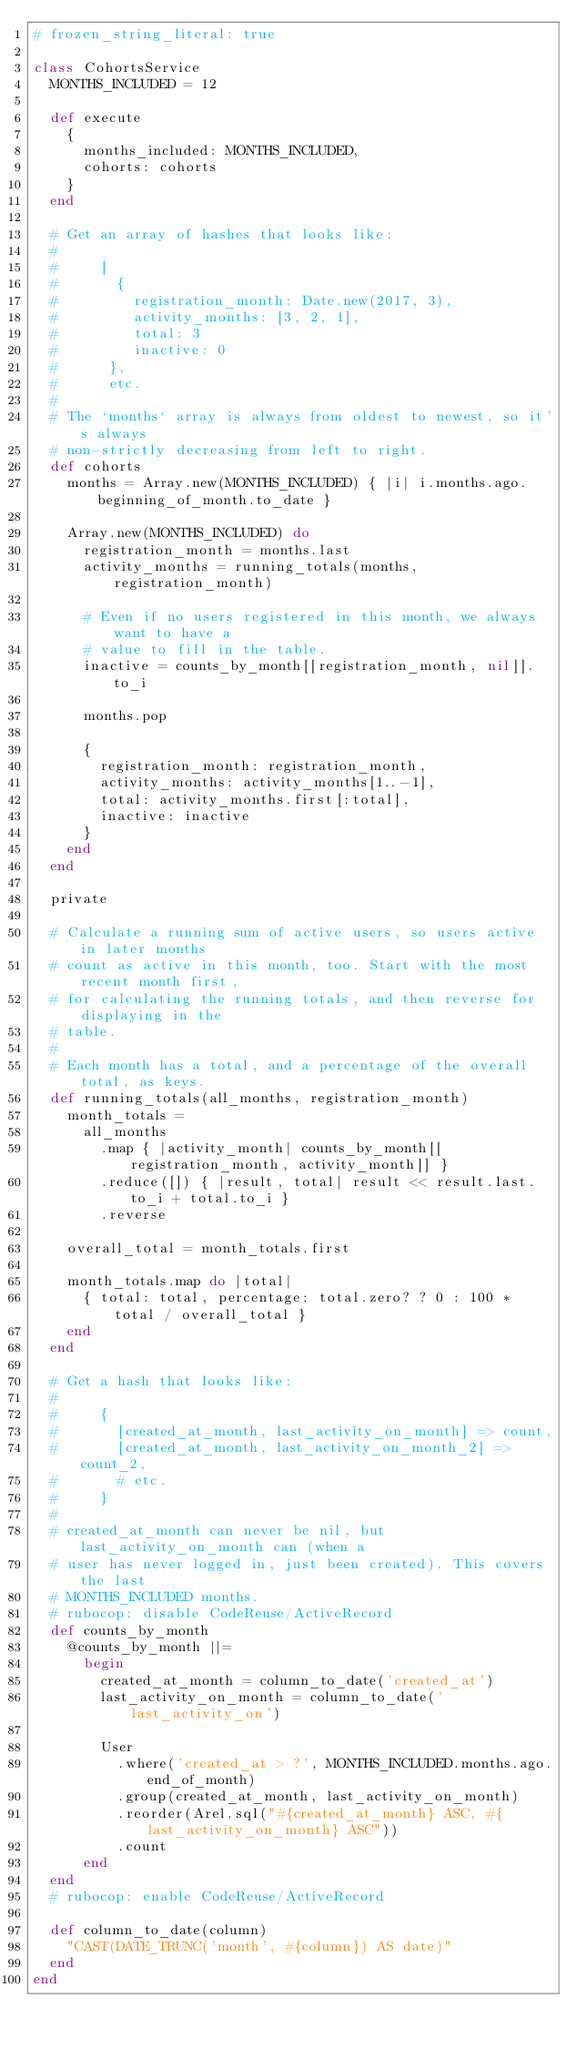Convert code to text. <code><loc_0><loc_0><loc_500><loc_500><_Ruby_># frozen_string_literal: true

class CohortsService
  MONTHS_INCLUDED = 12

  def execute
    {
      months_included: MONTHS_INCLUDED,
      cohorts: cohorts
    }
  end

  # Get an array of hashes that looks like:
  #
  #     [
  #       {
  #         registration_month: Date.new(2017, 3),
  #         activity_months: [3, 2, 1],
  #         total: 3
  #         inactive: 0
  #      },
  #      etc.
  #
  # The `months` array is always from oldest to newest, so it's always
  # non-strictly decreasing from left to right.
  def cohorts
    months = Array.new(MONTHS_INCLUDED) { |i| i.months.ago.beginning_of_month.to_date }

    Array.new(MONTHS_INCLUDED) do
      registration_month = months.last
      activity_months = running_totals(months, registration_month)

      # Even if no users registered in this month, we always want to have a
      # value to fill in the table.
      inactive = counts_by_month[[registration_month, nil]].to_i

      months.pop

      {
        registration_month: registration_month,
        activity_months: activity_months[1..-1],
        total: activity_months.first[:total],
        inactive: inactive
      }
    end
  end

  private

  # Calculate a running sum of active users, so users active in later months
  # count as active in this month, too. Start with the most recent month first,
  # for calculating the running totals, and then reverse for displaying in the
  # table.
  #
  # Each month has a total, and a percentage of the overall total, as keys.
  def running_totals(all_months, registration_month)
    month_totals =
      all_months
        .map { |activity_month| counts_by_month[[registration_month, activity_month]] }
        .reduce([]) { |result, total| result << result.last.to_i + total.to_i }
        .reverse

    overall_total = month_totals.first

    month_totals.map do |total|
      { total: total, percentage: total.zero? ? 0 : 100 * total / overall_total }
    end
  end

  # Get a hash that looks like:
  #
  #     {
  #       [created_at_month, last_activity_on_month] => count,
  #       [created_at_month, last_activity_on_month_2] => count_2,
  #       # etc.
  #     }
  #
  # created_at_month can never be nil, but last_activity_on_month can (when a
  # user has never logged in, just been created). This covers the last
  # MONTHS_INCLUDED months.
  # rubocop: disable CodeReuse/ActiveRecord
  def counts_by_month
    @counts_by_month ||=
      begin
        created_at_month = column_to_date('created_at')
        last_activity_on_month = column_to_date('last_activity_on')

        User
          .where('created_at > ?', MONTHS_INCLUDED.months.ago.end_of_month)
          .group(created_at_month, last_activity_on_month)
          .reorder(Arel.sql("#{created_at_month} ASC, #{last_activity_on_month} ASC"))
          .count
      end
  end
  # rubocop: enable CodeReuse/ActiveRecord

  def column_to_date(column)
    "CAST(DATE_TRUNC('month', #{column}) AS date)"
  end
end
</code> 